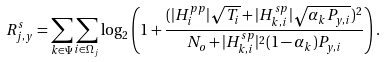Convert formula to latex. <formula><loc_0><loc_0><loc_500><loc_500>R _ { j , y } ^ { s } = \sum _ { k \in \Psi } \sum _ { i \in \Omega _ { j } } \log _ { 2 } \left ( 1 + \frac { ( | H _ { i } ^ { p p } | \sqrt { T _ { i } } + | H _ { k , i } ^ { s p } | \sqrt { \alpha _ { k } P _ { y , i } } ) ^ { 2 } } { N _ { o } + | H _ { k , i } ^ { s p } | ^ { 2 } ( 1 - \alpha _ { k } ) P _ { y , i } } \right ) .</formula> 